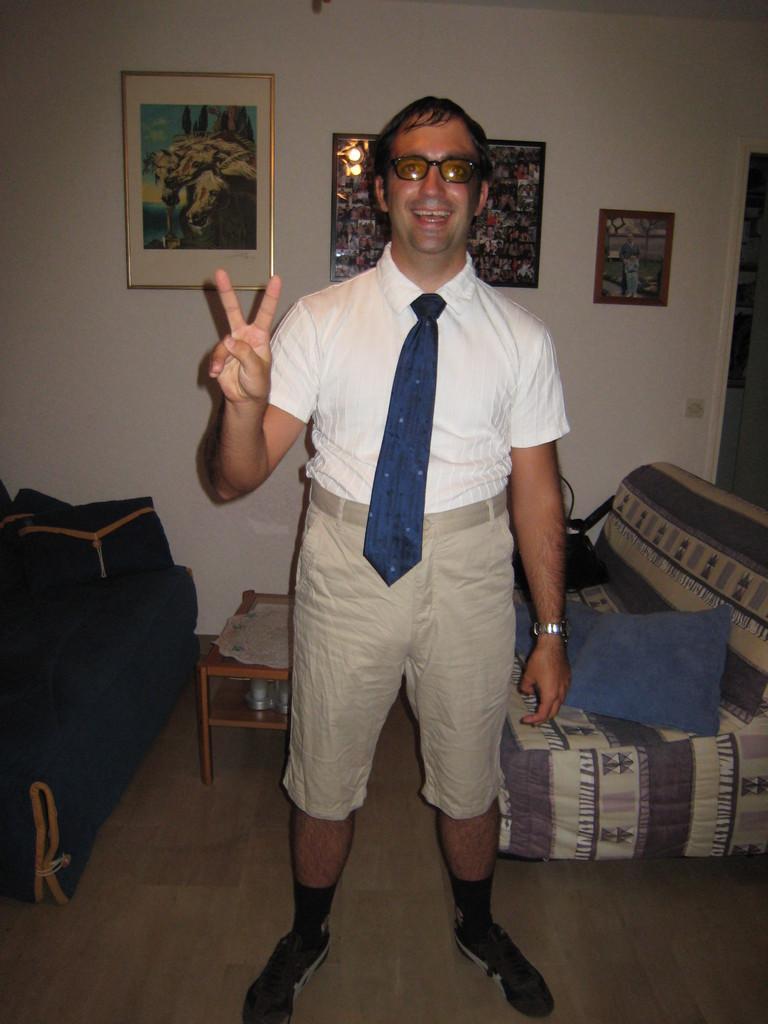Please provide a concise description of this image. This is the man standing. He wore white shirt,tie,short and shoes. This is a couch with a blue color cushion on it. I can see a small table with an object placed on it. These are the frames attached to the wall. This is the floor. 